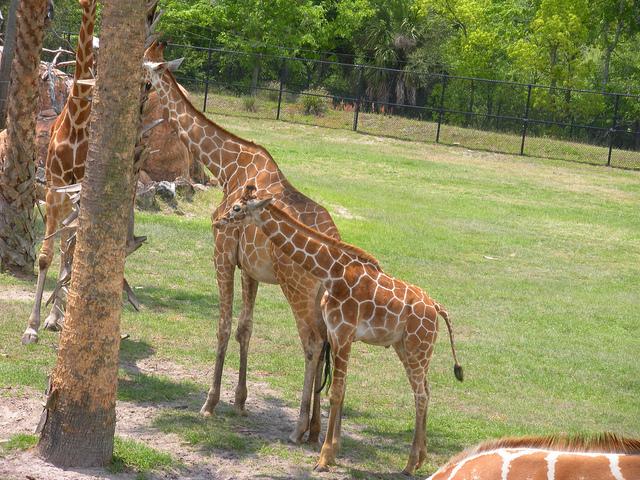How are the giraffes contained?
Short answer required. Fence. Which giraffe is the mother?
Concise answer only. Tall one. Are these animals in the wild?
Be succinct. No. 